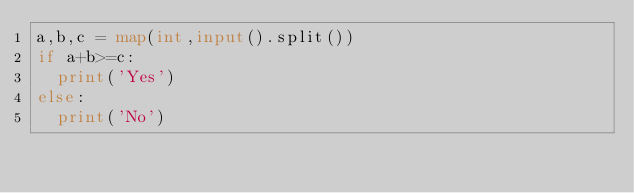<code> <loc_0><loc_0><loc_500><loc_500><_Python_>a,b,c = map(int,input().split())
if a+b>=c:
  print('Yes')
else:
  print('No')
</code> 